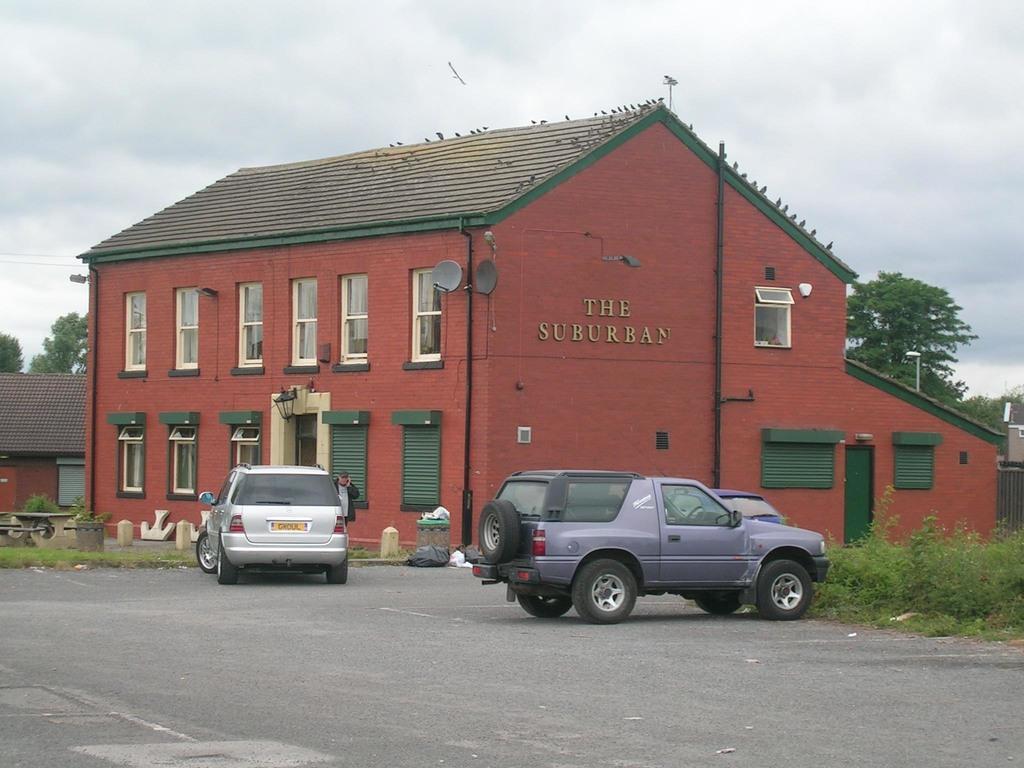Could you give a brief overview of what you see in this image? In this picture I can see the building and shed. At the bottom there is a grey car which is parked near to the grass. On the left there is a man who is standing near to the silver color car. At the top I can see the sky and clouds. In the center there is a dustbin near to the black pole. On the roof of the building I can see many birds were standing. 